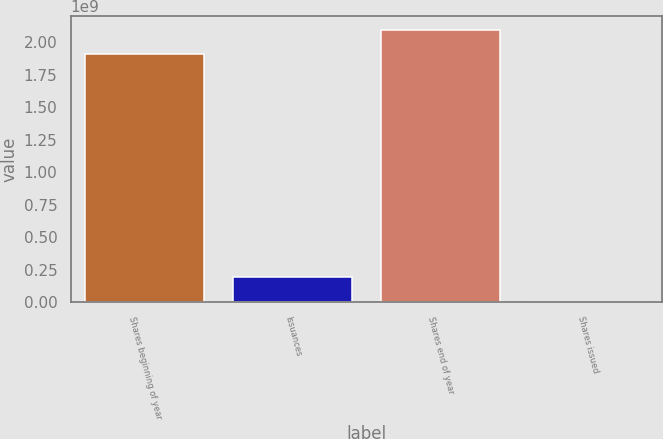<chart> <loc_0><loc_0><loc_500><loc_500><bar_chart><fcel>Shares beginning of year<fcel>Issuances<fcel>Shares end of year<fcel>Shares issued<nl><fcel>1.90657e+09<fcel>1.90692e+08<fcel>2.09723e+09<fcel>34009<nl></chart> 